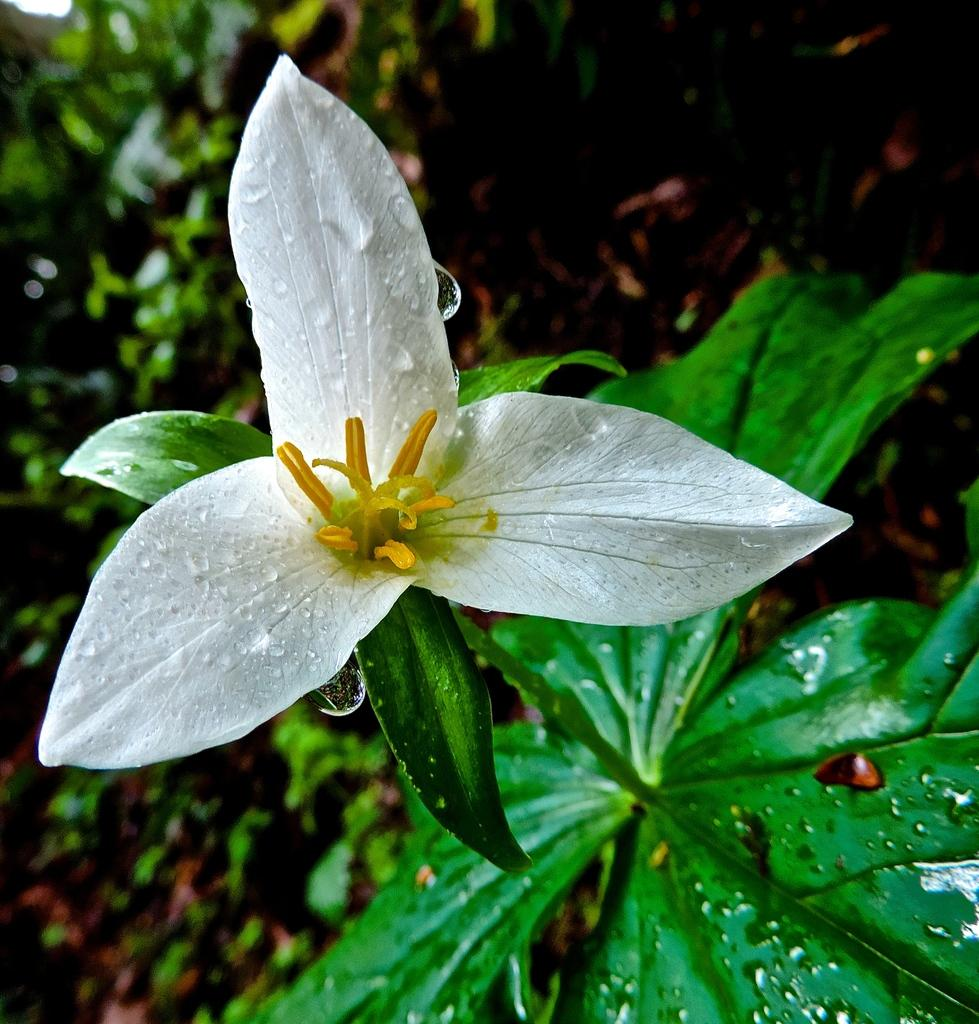What type of plant is featured in the image? There is a plant with a white flower in the image. Are there any other plants visible in the image? Yes, there are other plants in the image. What can be seen on the ground in the background of the image? There are dried leaves on the ground in the background. How would you describe the lighting in the image? The background of the image is dark. What time is displayed on the clock in the image? There is no clock present in the image. Can you describe the interaction between the plant and the friend in the image? There is no friend present in the image, and the plant is not interacting with anyone. --- Facts: 1. There is a person sitting on a bench in the image. 2. The person is reading a book. 3. The bench is located in a park. 4. There are trees in the background. 5. The sky is visible in the image. What is the person in the image doing? The person is sitting on a bench and reading a book. Where is the bench located? The bench is located in a park. What can be seen in the background of the image? There are trees in the background. What is visible at the top of the image? The sky is visible in the image. Reasoning: Let's think step by step in order to produce the conversation. We start by identifying the main subject of the image, which is the person sitting on the bench. Then, we describe what the person is doing, which is reading a book. Next, we provide information about the location of the bench, which is in a park. Finally, we mention the background and the sky, which are visible in the image. Absurd Question/Answer: What type of ice cream is the person eating in the image? There is no ice cream present in the image; the person is reading a book. Can you describe the interaction between the person and the dog in the image? There is no dog present in the image, and the person is sitting alone on the bench. 